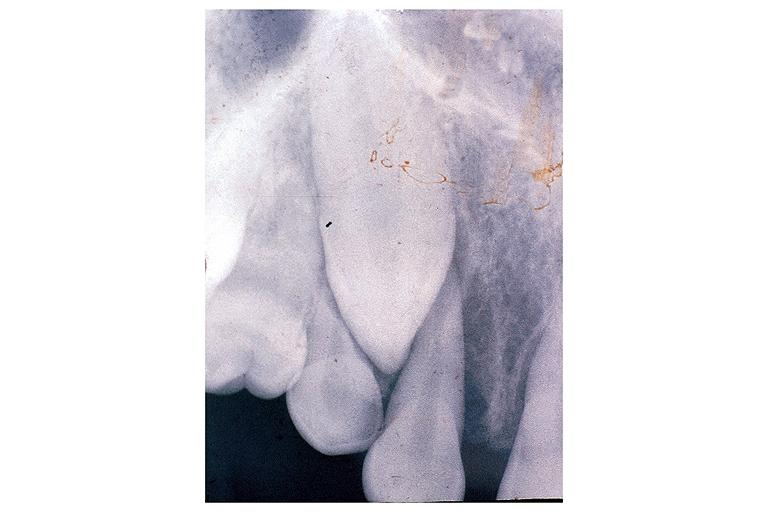s histiocyte present?
Answer the question using a single word or phrase. No 